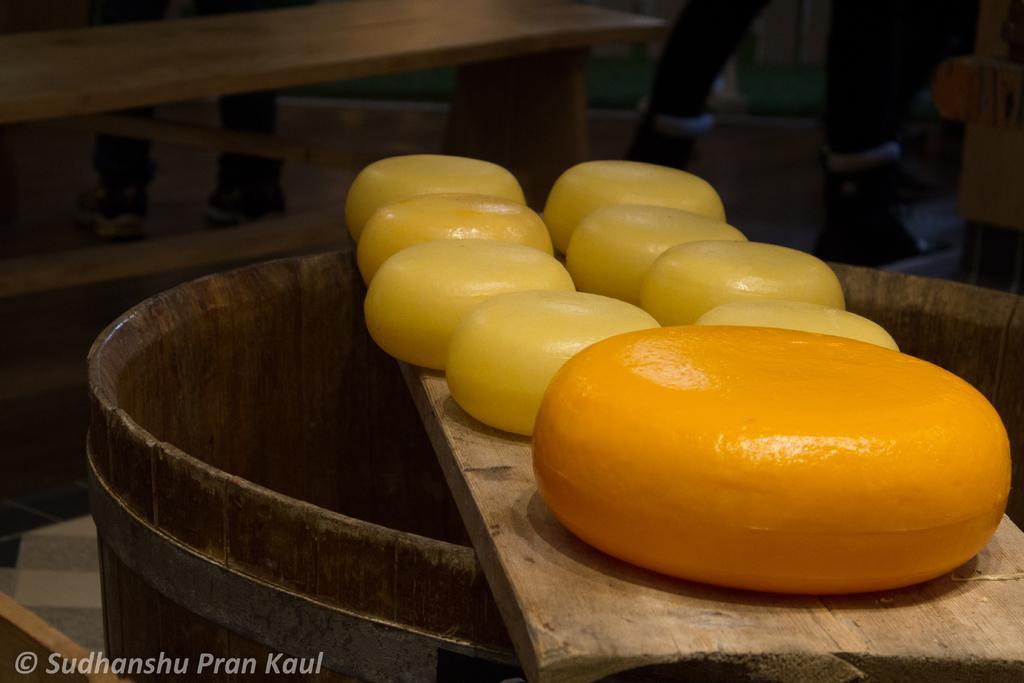Could you give a brief overview of what you see in this image? In this picture we can see wood in the front, there is some cheese placed on this weed, it looks like a barrel at the bottom, we can see some text at the bottom, in the background there are legs of two persons. 